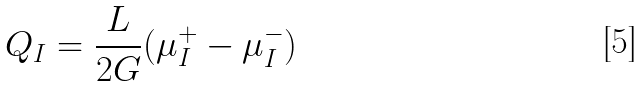<formula> <loc_0><loc_0><loc_500><loc_500>Q _ { I } = \frac { L } { 2 G } ( \mu _ { I } ^ { + } - \mu _ { I } ^ { - } )</formula> 